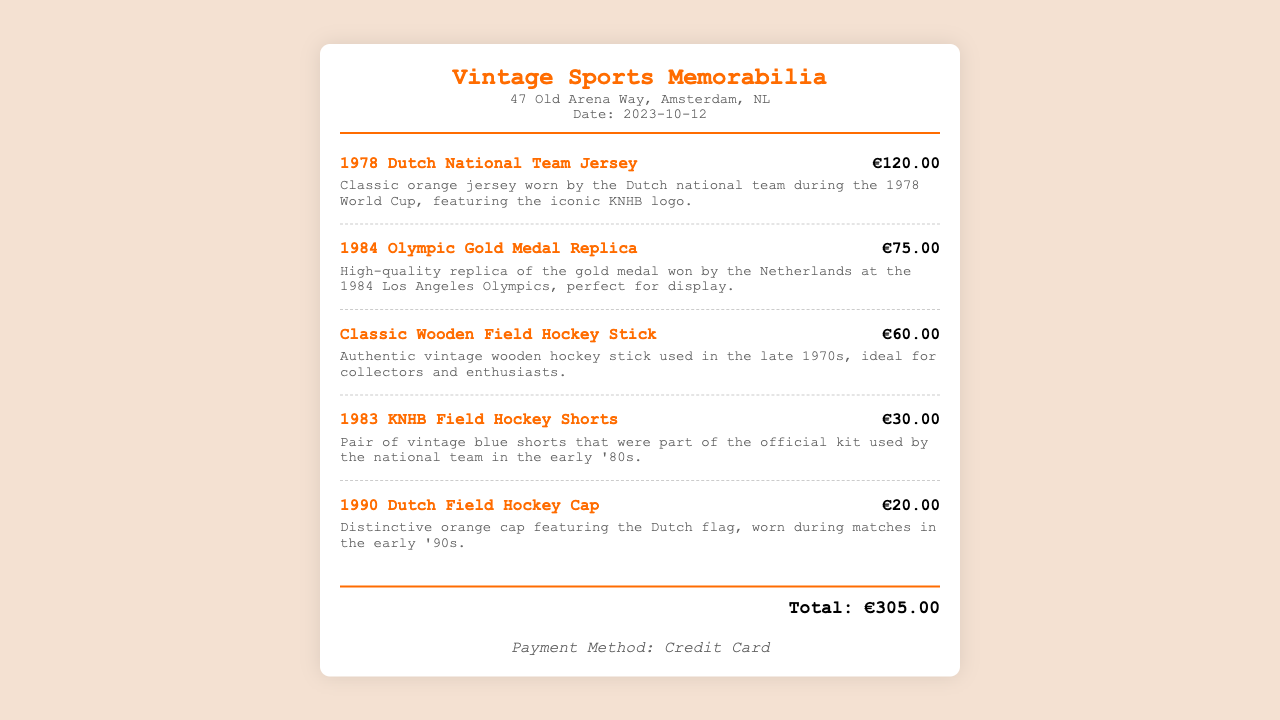What is the shop name? The shop name is prominently displayed at the top of the receipt, indicating where the purchase was made.
Answer: Vintage Sports Memorabilia What is the date of the transaction? The date is listed beneath the shop's address on the receipt, marking when the purchase occurred.
Answer: 2023-10-12 How much did the 1978 Dutch National Team Jersey cost? The price for this specific item is clearly shown next to its description, reflecting its size and value.
Answer: €120.00 What was the total amount spent on the receipt? The total amount represents the sum of all items purchased, located prominently at the bottom of the receipt.
Answer: €305.00 Which item was associated with the 1984 Olympics? The item related to the 1984 Olympics is mentioned in the receipt with its description, indicating its historical significance.
Answer: 1984 Olympic Gold Medal Replica How many items were listed on the receipt? The items are itemized one by one, and counting them gives the total number listed in the transaction.
Answer: 5 What color are the 1983 KNHB Field Hockey Shorts? The color of this specific item is described in its detail, reflecting its design features and uniqueness.
Answer: Blue What payment method was used? The payment method is specified at the bottom of the receipt, indicating how the purchase was completed.
Answer: Credit Card What feature distinguishes the 1990 Dutch Field Hockey Cap? The description details a specific element related to this cap, making it a notable piece of memorabilia.
Answer: Dutch flag 